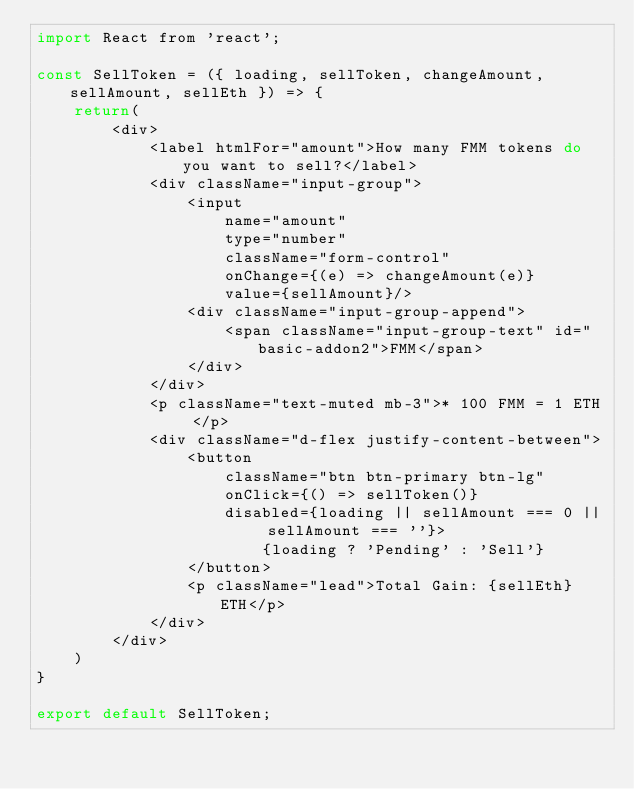<code> <loc_0><loc_0><loc_500><loc_500><_JavaScript_>import React from 'react';

const SellToken = ({ loading, sellToken, changeAmount, sellAmount, sellEth }) => {
    return(
        <div>
            <label htmlFor="amount">How many FMM tokens do you want to sell?</label>
            <div className="input-group">
                <input
                    name="amount"
                    type="number"
                    className="form-control"
                    onChange={(e) => changeAmount(e)}
                    value={sellAmount}/>
                <div className="input-group-append">
                    <span className="input-group-text" id="basic-addon2">FMM</span>
                </div>
            </div>
            <p className="text-muted mb-3">* 100 FMM = 1 ETH </p>
            <div className="d-flex justify-content-between">
                <button
                    className="btn btn-primary btn-lg"
                    onClick={() => sellToken()}
                    disabled={loading || sellAmount === 0 || sellAmount === ''}>
                        {loading ? 'Pending' : 'Sell'}
                </button>
                <p className="lead">Total Gain: {sellEth} ETH</p>
            </div>
        </div>
    )
}

export default SellToken;</code> 